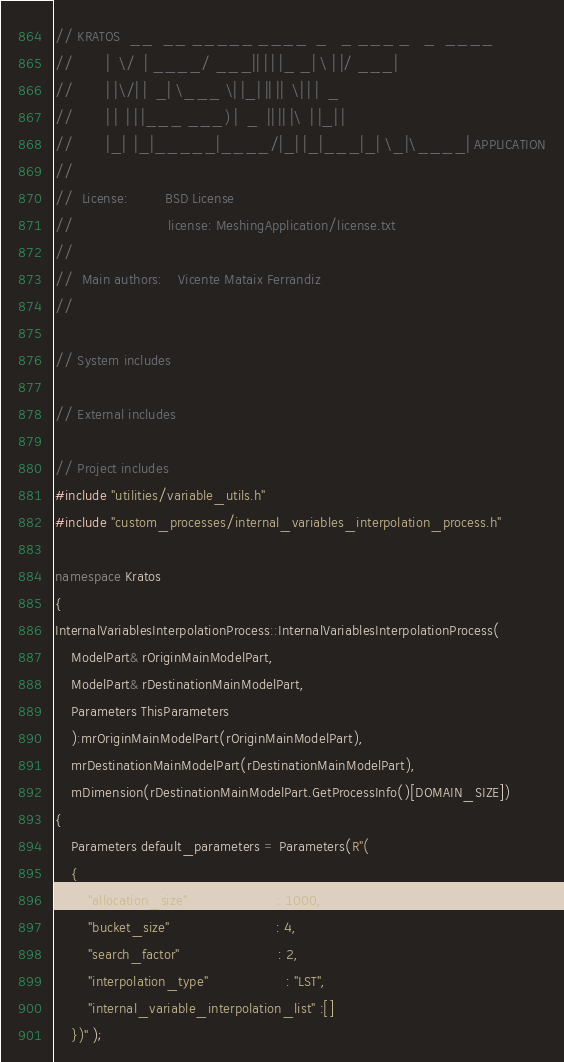Convert code to text. <code><loc_0><loc_0><loc_500><loc_500><_C++_>// KRATOS  __  __ _____ ____  _   _ ___ _   _  ____
//        |  \/  | ____/ ___|| | | |_ _| \ | |/ ___|
//        | |\/| |  _| \___ \| |_| || ||  \| | |  _
//        | |  | | |___ ___) |  _  || || |\  | |_| |
//        |_|  |_|_____|____/|_| |_|___|_| \_|\____| APPLICATION
//
//  License:		 BSD License
//                       license: MeshingApplication/license.txt
//
//  Main authors:    Vicente Mataix Ferrandiz
//

// System includes

// External includes

// Project includes
#include "utilities/variable_utils.h"
#include "custom_processes/internal_variables_interpolation_process.h"

namespace Kratos
{
InternalVariablesInterpolationProcess::InternalVariablesInterpolationProcess(
    ModelPart& rOriginMainModelPart,
    ModelPart& rDestinationMainModelPart,
    Parameters ThisParameters
    ):mrOriginMainModelPart(rOriginMainModelPart),
    mrDestinationMainModelPart(rDestinationMainModelPart),
    mDimension(rDestinationMainModelPart.GetProcessInfo()[DOMAIN_SIZE])
{
    Parameters default_parameters = Parameters(R"(
    {
        "allocation_size"                      : 1000,
        "bucket_size"                          : 4,
        "search_factor"                        : 2,
        "interpolation_type"                   : "LST",
        "internal_variable_interpolation_list" :[]
    })" );
</code> 